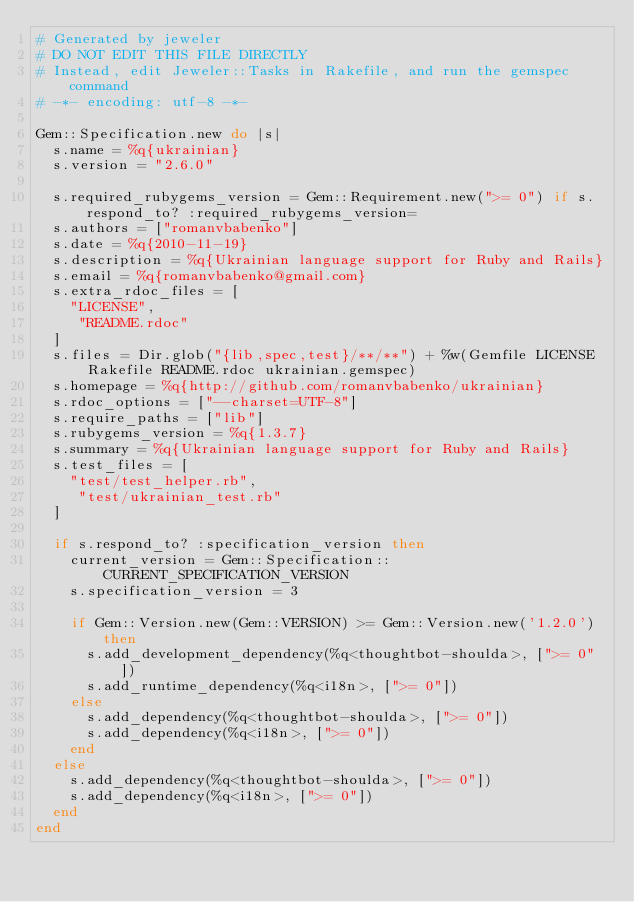<code> <loc_0><loc_0><loc_500><loc_500><_Ruby_># Generated by jeweler
# DO NOT EDIT THIS FILE DIRECTLY
# Instead, edit Jeweler::Tasks in Rakefile, and run the gemspec command
# -*- encoding: utf-8 -*-

Gem::Specification.new do |s|
  s.name = %q{ukrainian}
  s.version = "2.6.0"

  s.required_rubygems_version = Gem::Requirement.new(">= 0") if s.respond_to? :required_rubygems_version=
  s.authors = ["romanvbabenko"]
  s.date = %q{2010-11-19}
  s.description = %q{Ukrainian language support for Ruby and Rails}
  s.email = %q{romanvbabenko@gmail.com}
  s.extra_rdoc_files = [
    "LICENSE",
     "README.rdoc"
  ]
  s.files = Dir.glob("{lib,spec,test}/**/**") + %w(Gemfile LICENSE Rakefile README.rdoc ukrainian.gemspec)
  s.homepage = %q{http://github.com/romanvbabenko/ukrainian}
  s.rdoc_options = ["--charset=UTF-8"]
  s.require_paths = ["lib"]
  s.rubygems_version = %q{1.3.7}
  s.summary = %q{Ukrainian language support for Ruby and Rails}
  s.test_files = [
    "test/test_helper.rb",
     "test/ukrainian_test.rb"
  ]

  if s.respond_to? :specification_version then
    current_version = Gem::Specification::CURRENT_SPECIFICATION_VERSION
    s.specification_version = 3

    if Gem::Version.new(Gem::VERSION) >= Gem::Version.new('1.2.0') then
      s.add_development_dependency(%q<thoughtbot-shoulda>, [">= 0"])
      s.add_runtime_dependency(%q<i18n>, [">= 0"])
    else
      s.add_dependency(%q<thoughtbot-shoulda>, [">= 0"])
      s.add_dependency(%q<i18n>, [">= 0"])
    end
  else
    s.add_dependency(%q<thoughtbot-shoulda>, [">= 0"])
    s.add_dependency(%q<i18n>, [">= 0"])
  end
end
</code> 